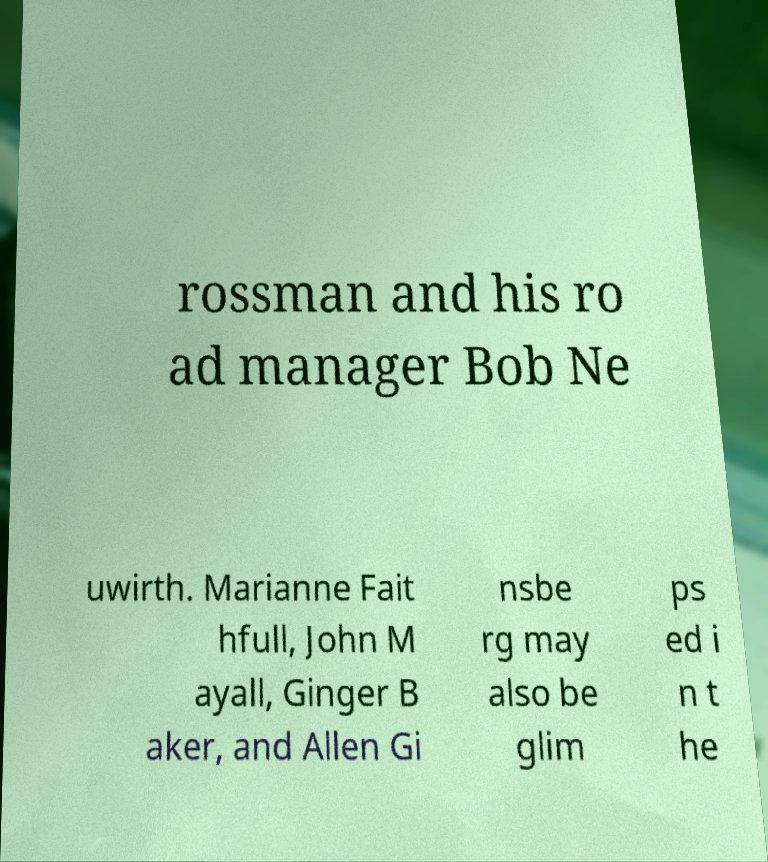I need the written content from this picture converted into text. Can you do that? rossman and his ro ad manager Bob Ne uwirth. Marianne Fait hfull, John M ayall, Ginger B aker, and Allen Gi nsbe rg may also be glim ps ed i n t he 